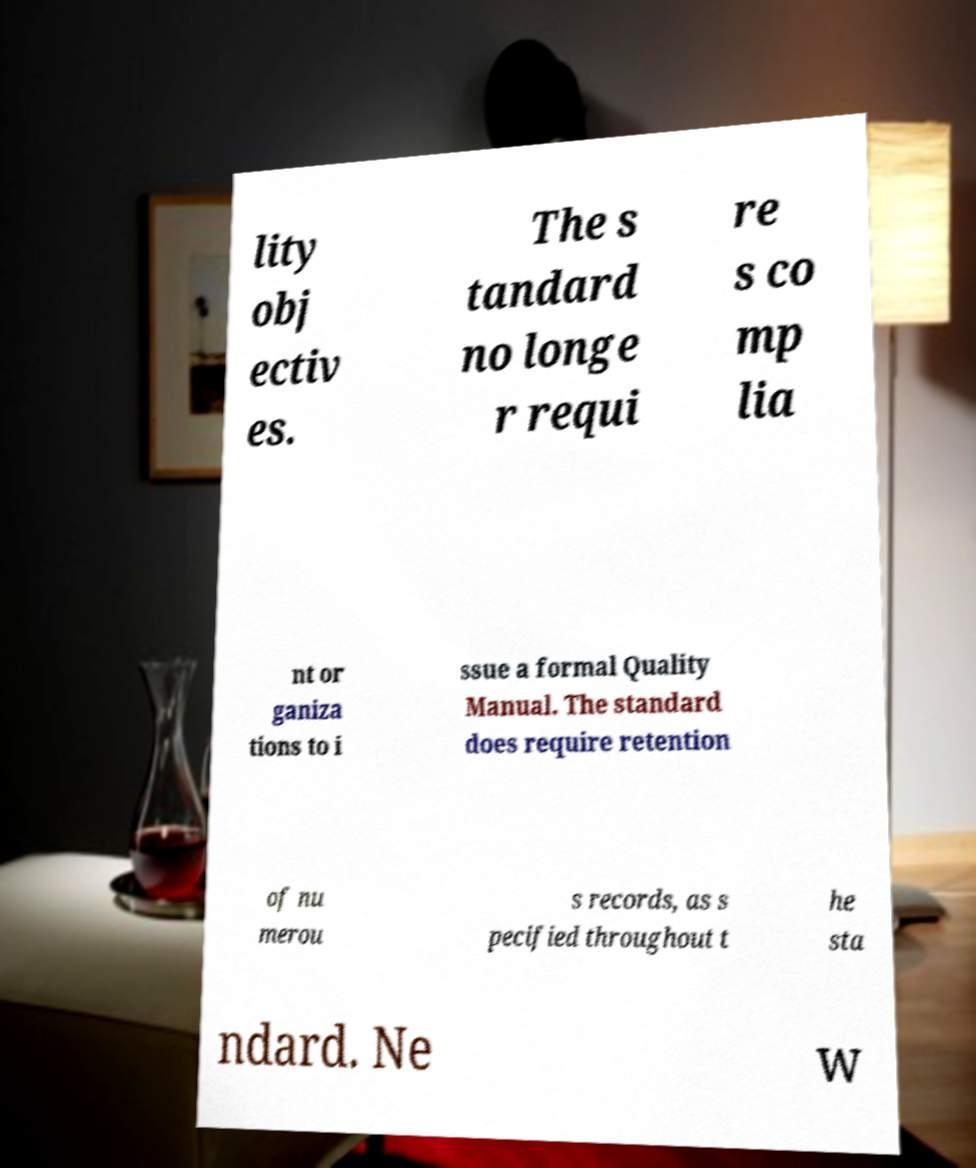For documentation purposes, I need the text within this image transcribed. Could you provide that? lity obj ectiv es. The s tandard no longe r requi re s co mp lia nt or ganiza tions to i ssue a formal Quality Manual. The standard does require retention of nu merou s records, as s pecified throughout t he sta ndard. Ne w 